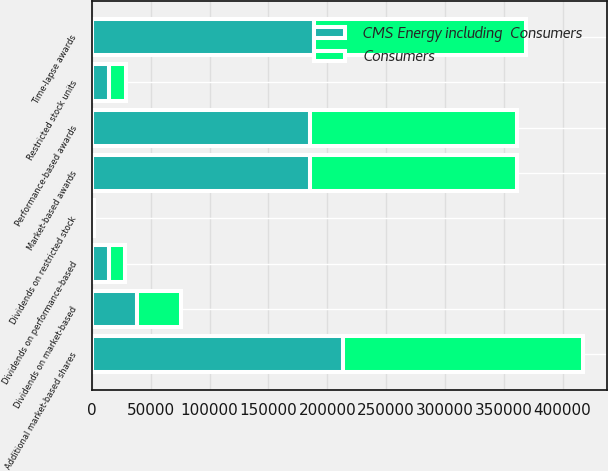Convert chart to OTSL. <chart><loc_0><loc_0><loc_500><loc_500><stacked_bar_chart><ecel><fcel>Time-lapse awards<fcel>Market-based awards<fcel>Performance-based awards<fcel>Restricted stock units<fcel>Dividends on market-based<fcel>Dividends on performance-based<fcel>Dividends on restricted stock<fcel>Additional market-based shares<nl><fcel>CMS Energy including  Consumers<fcel>188303<fcel>185464<fcel>185464<fcel>14595<fcel>38652<fcel>14438<fcel>743<fcel>213754<nl><fcel>Consumers<fcel>180958<fcel>175818<fcel>175818<fcel>14186<fcel>36646<fcel>13704<fcel>721<fcel>203384<nl></chart> 